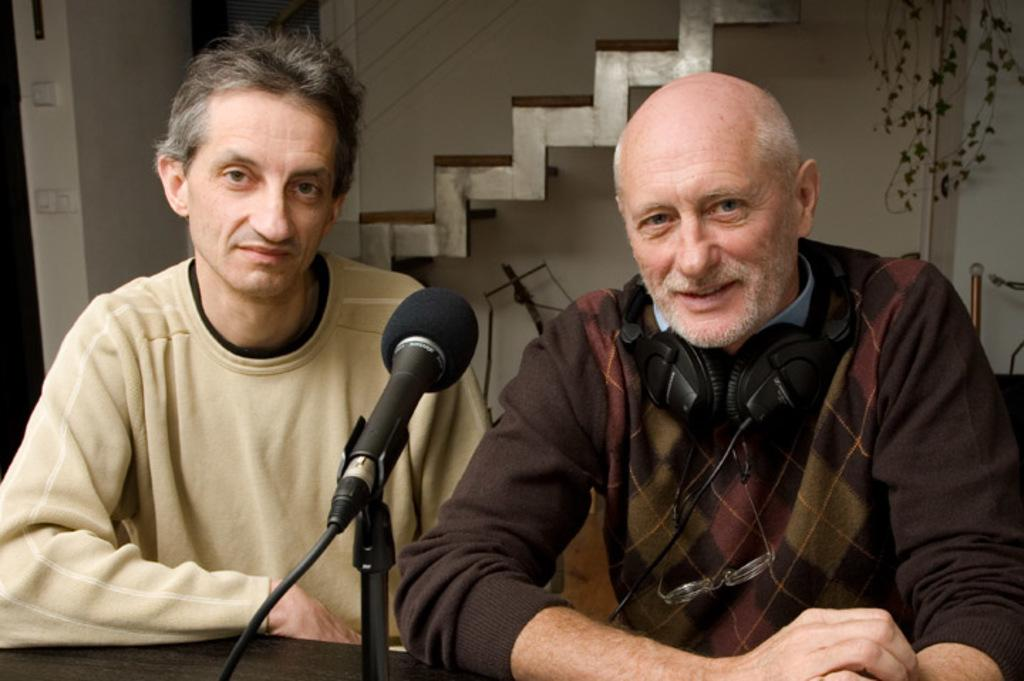How many people are present in the image? There are two men sitting in the image. What object is placed on the table in front of the men? There is a microphone with a stand on a table in front of the men. What can be seen in the background of the image? There are stairs, a wall, and a plant in the background of the image. What type of horn can be heard in the image? There is no horn present in the image, and therefore no sound can be heard. 